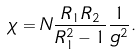Convert formula to latex. <formula><loc_0><loc_0><loc_500><loc_500>\chi = N \frac { R _ { 1 } R _ { 2 } } { R _ { 1 } ^ { 2 } - 1 } \frac { 1 } { g ^ { 2 } } .</formula> 